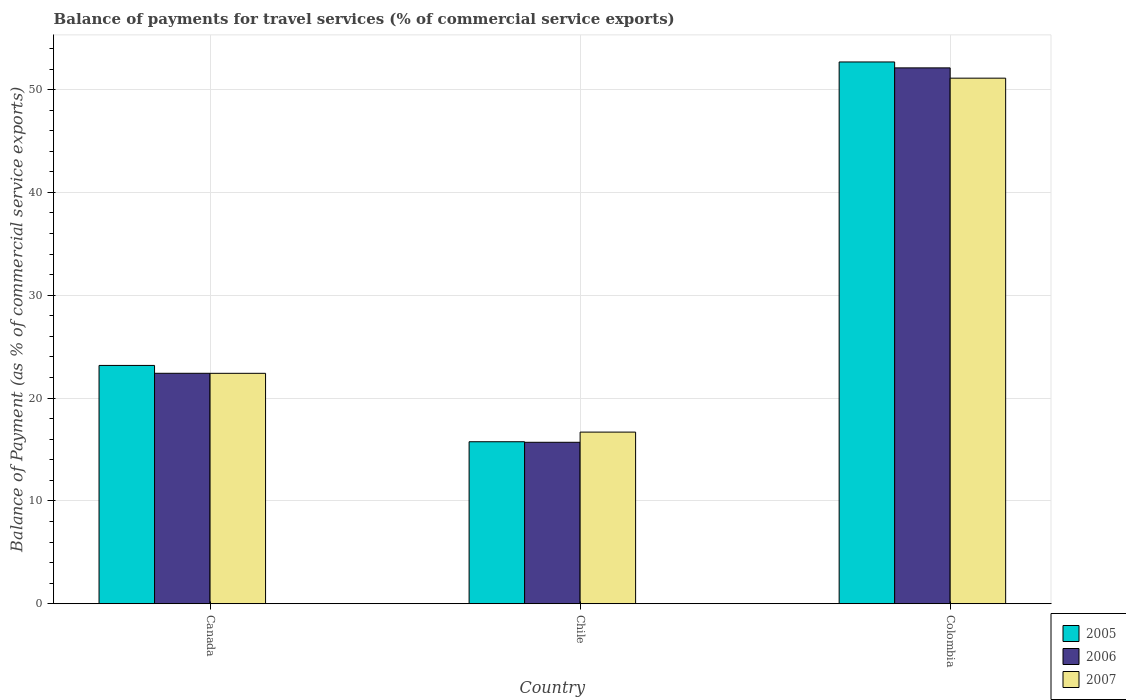How many different coloured bars are there?
Make the answer very short. 3. Are the number of bars per tick equal to the number of legend labels?
Make the answer very short. Yes. How many bars are there on the 2nd tick from the left?
Make the answer very short. 3. How many bars are there on the 1st tick from the right?
Offer a very short reply. 3. What is the label of the 2nd group of bars from the left?
Your response must be concise. Chile. What is the balance of payments for travel services in 2006 in Canada?
Your answer should be compact. 22.41. Across all countries, what is the maximum balance of payments for travel services in 2005?
Provide a succinct answer. 52.69. Across all countries, what is the minimum balance of payments for travel services in 2005?
Make the answer very short. 15.75. In which country was the balance of payments for travel services in 2005 minimum?
Offer a terse response. Chile. What is the total balance of payments for travel services in 2005 in the graph?
Your answer should be compact. 91.61. What is the difference between the balance of payments for travel services in 2006 in Canada and that in Chile?
Give a very brief answer. 6.71. What is the difference between the balance of payments for travel services in 2006 in Colombia and the balance of payments for travel services in 2005 in Chile?
Provide a succinct answer. 36.36. What is the average balance of payments for travel services in 2006 per country?
Your response must be concise. 30.07. What is the difference between the balance of payments for travel services of/in 2006 and balance of payments for travel services of/in 2005 in Colombia?
Provide a succinct answer. -0.58. In how many countries, is the balance of payments for travel services in 2005 greater than 42 %?
Your answer should be compact. 1. What is the ratio of the balance of payments for travel services in 2006 in Canada to that in Colombia?
Your answer should be compact. 0.43. What is the difference between the highest and the second highest balance of payments for travel services in 2007?
Keep it short and to the point. -34.42. What is the difference between the highest and the lowest balance of payments for travel services in 2006?
Your answer should be compact. 36.41. What does the 3rd bar from the left in Chile represents?
Your answer should be compact. 2007. What does the 2nd bar from the right in Chile represents?
Your response must be concise. 2006. Is it the case that in every country, the sum of the balance of payments for travel services in 2006 and balance of payments for travel services in 2007 is greater than the balance of payments for travel services in 2005?
Provide a short and direct response. Yes. What is the difference between two consecutive major ticks on the Y-axis?
Give a very brief answer. 10. Are the values on the major ticks of Y-axis written in scientific E-notation?
Your answer should be compact. No. Where does the legend appear in the graph?
Ensure brevity in your answer.  Bottom right. How are the legend labels stacked?
Offer a terse response. Vertical. What is the title of the graph?
Your answer should be compact. Balance of payments for travel services (% of commercial service exports). What is the label or title of the X-axis?
Your answer should be very brief. Country. What is the label or title of the Y-axis?
Provide a short and direct response. Balance of Payment (as % of commercial service exports). What is the Balance of Payment (as % of commercial service exports) in 2005 in Canada?
Make the answer very short. 23.17. What is the Balance of Payment (as % of commercial service exports) of 2006 in Canada?
Provide a succinct answer. 22.41. What is the Balance of Payment (as % of commercial service exports) in 2007 in Canada?
Make the answer very short. 22.41. What is the Balance of Payment (as % of commercial service exports) of 2005 in Chile?
Give a very brief answer. 15.75. What is the Balance of Payment (as % of commercial service exports) in 2006 in Chile?
Provide a succinct answer. 15.7. What is the Balance of Payment (as % of commercial service exports) of 2007 in Chile?
Ensure brevity in your answer.  16.69. What is the Balance of Payment (as % of commercial service exports) of 2005 in Colombia?
Provide a succinct answer. 52.69. What is the Balance of Payment (as % of commercial service exports) of 2006 in Colombia?
Give a very brief answer. 52.11. What is the Balance of Payment (as % of commercial service exports) in 2007 in Colombia?
Your answer should be very brief. 51.11. Across all countries, what is the maximum Balance of Payment (as % of commercial service exports) in 2005?
Provide a short and direct response. 52.69. Across all countries, what is the maximum Balance of Payment (as % of commercial service exports) in 2006?
Offer a terse response. 52.11. Across all countries, what is the maximum Balance of Payment (as % of commercial service exports) of 2007?
Provide a succinct answer. 51.11. Across all countries, what is the minimum Balance of Payment (as % of commercial service exports) of 2005?
Give a very brief answer. 15.75. Across all countries, what is the minimum Balance of Payment (as % of commercial service exports) in 2006?
Keep it short and to the point. 15.7. Across all countries, what is the minimum Balance of Payment (as % of commercial service exports) of 2007?
Make the answer very short. 16.69. What is the total Balance of Payment (as % of commercial service exports) in 2005 in the graph?
Your answer should be very brief. 91.61. What is the total Balance of Payment (as % of commercial service exports) of 2006 in the graph?
Your response must be concise. 90.22. What is the total Balance of Payment (as % of commercial service exports) in 2007 in the graph?
Your response must be concise. 90.21. What is the difference between the Balance of Payment (as % of commercial service exports) in 2005 in Canada and that in Chile?
Ensure brevity in your answer.  7.42. What is the difference between the Balance of Payment (as % of commercial service exports) of 2006 in Canada and that in Chile?
Your answer should be compact. 6.71. What is the difference between the Balance of Payment (as % of commercial service exports) of 2007 in Canada and that in Chile?
Your answer should be compact. 5.72. What is the difference between the Balance of Payment (as % of commercial service exports) of 2005 in Canada and that in Colombia?
Provide a succinct answer. -29.51. What is the difference between the Balance of Payment (as % of commercial service exports) in 2006 in Canada and that in Colombia?
Keep it short and to the point. -29.7. What is the difference between the Balance of Payment (as % of commercial service exports) of 2007 in Canada and that in Colombia?
Ensure brevity in your answer.  -28.7. What is the difference between the Balance of Payment (as % of commercial service exports) of 2005 in Chile and that in Colombia?
Ensure brevity in your answer.  -36.93. What is the difference between the Balance of Payment (as % of commercial service exports) of 2006 in Chile and that in Colombia?
Keep it short and to the point. -36.41. What is the difference between the Balance of Payment (as % of commercial service exports) of 2007 in Chile and that in Colombia?
Your answer should be compact. -34.42. What is the difference between the Balance of Payment (as % of commercial service exports) of 2005 in Canada and the Balance of Payment (as % of commercial service exports) of 2006 in Chile?
Offer a terse response. 7.47. What is the difference between the Balance of Payment (as % of commercial service exports) in 2005 in Canada and the Balance of Payment (as % of commercial service exports) in 2007 in Chile?
Ensure brevity in your answer.  6.48. What is the difference between the Balance of Payment (as % of commercial service exports) of 2006 in Canada and the Balance of Payment (as % of commercial service exports) of 2007 in Chile?
Your answer should be very brief. 5.72. What is the difference between the Balance of Payment (as % of commercial service exports) of 2005 in Canada and the Balance of Payment (as % of commercial service exports) of 2006 in Colombia?
Your answer should be very brief. -28.94. What is the difference between the Balance of Payment (as % of commercial service exports) of 2005 in Canada and the Balance of Payment (as % of commercial service exports) of 2007 in Colombia?
Your answer should be very brief. -27.94. What is the difference between the Balance of Payment (as % of commercial service exports) of 2006 in Canada and the Balance of Payment (as % of commercial service exports) of 2007 in Colombia?
Your answer should be very brief. -28.7. What is the difference between the Balance of Payment (as % of commercial service exports) in 2005 in Chile and the Balance of Payment (as % of commercial service exports) in 2006 in Colombia?
Your response must be concise. -36.36. What is the difference between the Balance of Payment (as % of commercial service exports) in 2005 in Chile and the Balance of Payment (as % of commercial service exports) in 2007 in Colombia?
Keep it short and to the point. -35.36. What is the difference between the Balance of Payment (as % of commercial service exports) of 2006 in Chile and the Balance of Payment (as % of commercial service exports) of 2007 in Colombia?
Your response must be concise. -35.41. What is the average Balance of Payment (as % of commercial service exports) in 2005 per country?
Keep it short and to the point. 30.54. What is the average Balance of Payment (as % of commercial service exports) in 2006 per country?
Offer a terse response. 30.07. What is the average Balance of Payment (as % of commercial service exports) in 2007 per country?
Ensure brevity in your answer.  30.07. What is the difference between the Balance of Payment (as % of commercial service exports) in 2005 and Balance of Payment (as % of commercial service exports) in 2006 in Canada?
Keep it short and to the point. 0.76. What is the difference between the Balance of Payment (as % of commercial service exports) in 2005 and Balance of Payment (as % of commercial service exports) in 2007 in Canada?
Provide a succinct answer. 0.77. What is the difference between the Balance of Payment (as % of commercial service exports) of 2006 and Balance of Payment (as % of commercial service exports) of 2007 in Canada?
Your answer should be compact. 0. What is the difference between the Balance of Payment (as % of commercial service exports) in 2005 and Balance of Payment (as % of commercial service exports) in 2006 in Chile?
Offer a very short reply. 0.05. What is the difference between the Balance of Payment (as % of commercial service exports) in 2005 and Balance of Payment (as % of commercial service exports) in 2007 in Chile?
Offer a very short reply. -0.94. What is the difference between the Balance of Payment (as % of commercial service exports) of 2006 and Balance of Payment (as % of commercial service exports) of 2007 in Chile?
Make the answer very short. -0.99. What is the difference between the Balance of Payment (as % of commercial service exports) of 2005 and Balance of Payment (as % of commercial service exports) of 2006 in Colombia?
Offer a very short reply. 0.58. What is the difference between the Balance of Payment (as % of commercial service exports) in 2005 and Balance of Payment (as % of commercial service exports) in 2007 in Colombia?
Make the answer very short. 1.58. What is the difference between the Balance of Payment (as % of commercial service exports) of 2006 and Balance of Payment (as % of commercial service exports) of 2007 in Colombia?
Your answer should be compact. 1. What is the ratio of the Balance of Payment (as % of commercial service exports) in 2005 in Canada to that in Chile?
Provide a succinct answer. 1.47. What is the ratio of the Balance of Payment (as % of commercial service exports) of 2006 in Canada to that in Chile?
Make the answer very short. 1.43. What is the ratio of the Balance of Payment (as % of commercial service exports) of 2007 in Canada to that in Chile?
Provide a succinct answer. 1.34. What is the ratio of the Balance of Payment (as % of commercial service exports) in 2005 in Canada to that in Colombia?
Offer a terse response. 0.44. What is the ratio of the Balance of Payment (as % of commercial service exports) of 2006 in Canada to that in Colombia?
Your answer should be compact. 0.43. What is the ratio of the Balance of Payment (as % of commercial service exports) in 2007 in Canada to that in Colombia?
Ensure brevity in your answer.  0.44. What is the ratio of the Balance of Payment (as % of commercial service exports) in 2005 in Chile to that in Colombia?
Provide a succinct answer. 0.3. What is the ratio of the Balance of Payment (as % of commercial service exports) of 2006 in Chile to that in Colombia?
Provide a short and direct response. 0.3. What is the ratio of the Balance of Payment (as % of commercial service exports) in 2007 in Chile to that in Colombia?
Your response must be concise. 0.33. What is the difference between the highest and the second highest Balance of Payment (as % of commercial service exports) in 2005?
Your answer should be compact. 29.51. What is the difference between the highest and the second highest Balance of Payment (as % of commercial service exports) in 2006?
Give a very brief answer. 29.7. What is the difference between the highest and the second highest Balance of Payment (as % of commercial service exports) in 2007?
Provide a succinct answer. 28.7. What is the difference between the highest and the lowest Balance of Payment (as % of commercial service exports) of 2005?
Make the answer very short. 36.93. What is the difference between the highest and the lowest Balance of Payment (as % of commercial service exports) in 2006?
Keep it short and to the point. 36.41. What is the difference between the highest and the lowest Balance of Payment (as % of commercial service exports) in 2007?
Give a very brief answer. 34.42. 